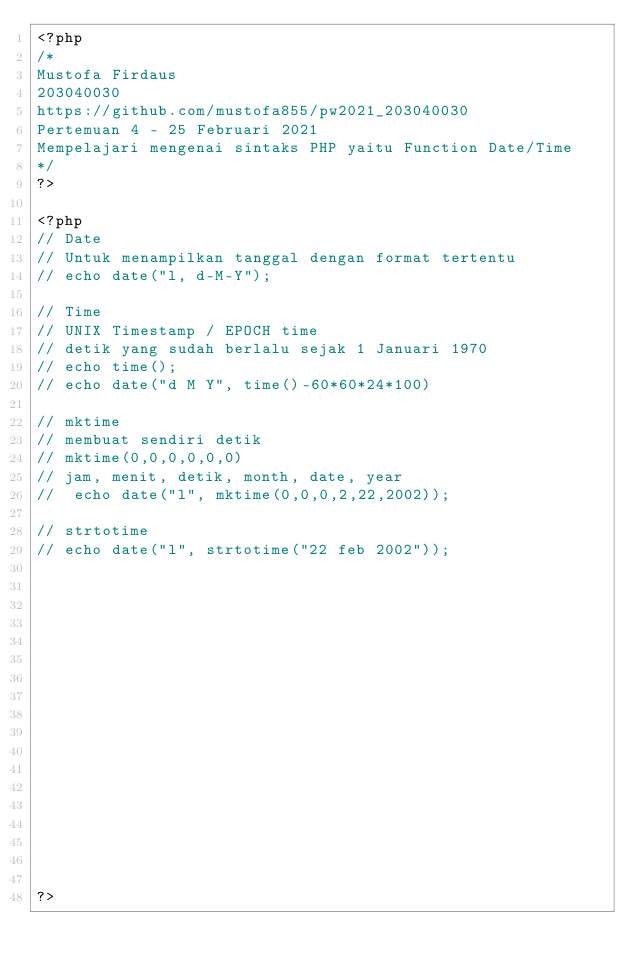Convert code to text. <code><loc_0><loc_0><loc_500><loc_500><_PHP_><?php 
/*
Mustofa Firdaus
203040030
https://github.com/mustofa855/pw2021_203040030
Pertemuan 4 - 25 Februari 2021
Mempelajari mengenai sintaks PHP yaitu Function Date/Time
*/
?>

<?php
// Date
// Untuk menampilkan tanggal dengan format tertentu
// echo date("l, d-M-Y");

// Time
// UNIX Timestamp / EPOCH time
// detik yang sudah berlalu sejak 1 Januari 1970
// echo time();
// echo date("d M Y", time()-60*60*24*100)

// mktime
// membuat sendiri detik
// mktime(0,0,0,0,0,0)
// jam, menit, detik, month, date, year
//  echo date("l", mktime(0,0,0,2,22,2002));

// strtotime
// echo date("l", strtotime("22 feb 2002"));


















?></code> 